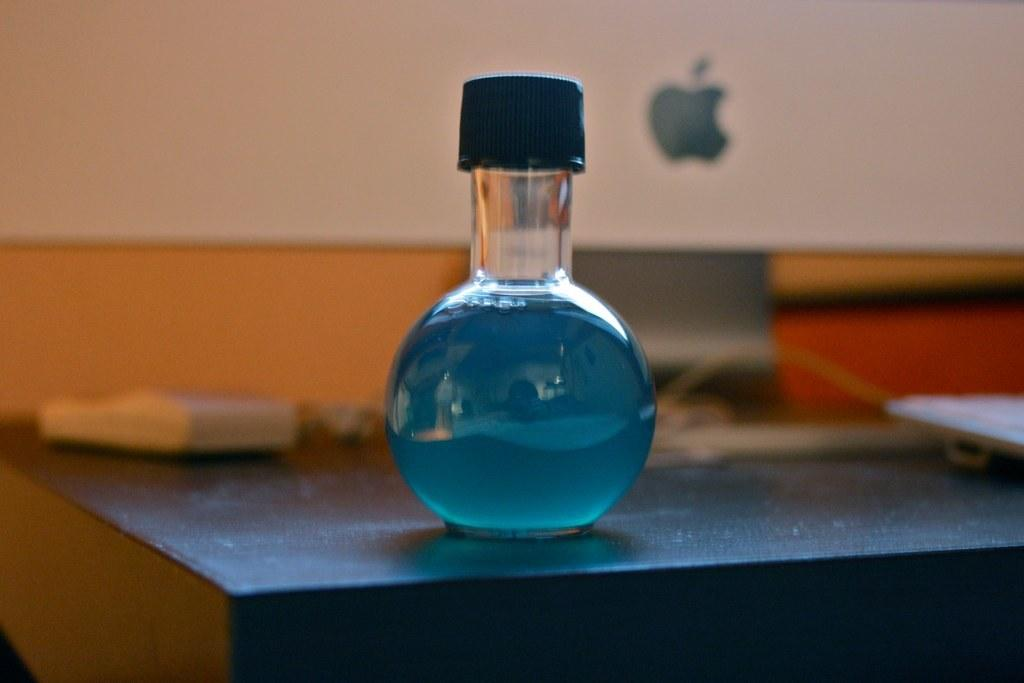What is in the beaker that is visible in the image? There is a beaker with a cap in the image. Where is the beaker located in the image? The beaker is on a table in the image. What can be seen in the background of the image? There is an Apple monitor in the background of the image. What type of flowers are on the boundary of the image? There are no flowers or boundaries present in the image; it only features a beaker with a cap on a table and an Apple monitor in the background. 